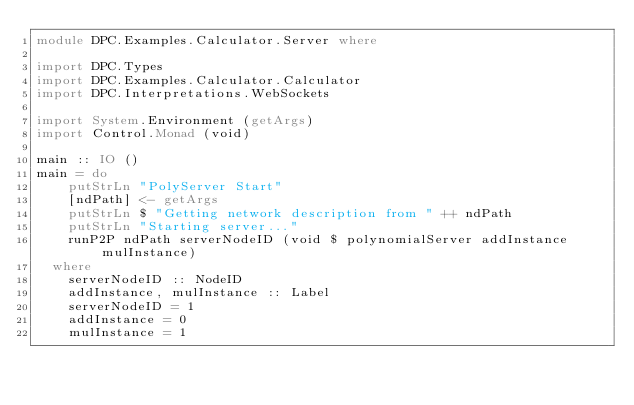Convert code to text. <code><loc_0><loc_0><loc_500><loc_500><_Haskell_>module DPC.Examples.Calculator.Server where

import DPC.Types
import DPC.Examples.Calculator.Calculator
import DPC.Interpretations.WebSockets

import System.Environment (getArgs)
import Control.Monad (void)

main :: IO ()
main = do
    putStrLn "PolyServer Start"
    [ndPath] <- getArgs
    putStrLn $ "Getting network description from " ++ ndPath
    putStrLn "Starting server..."
    runP2P ndPath serverNodeID (void $ polynomialServer addInstance mulInstance)
  where
    serverNodeID :: NodeID
    addInstance, mulInstance :: Label
    serverNodeID = 1
    addInstance = 0
    mulInstance = 1
</code> 